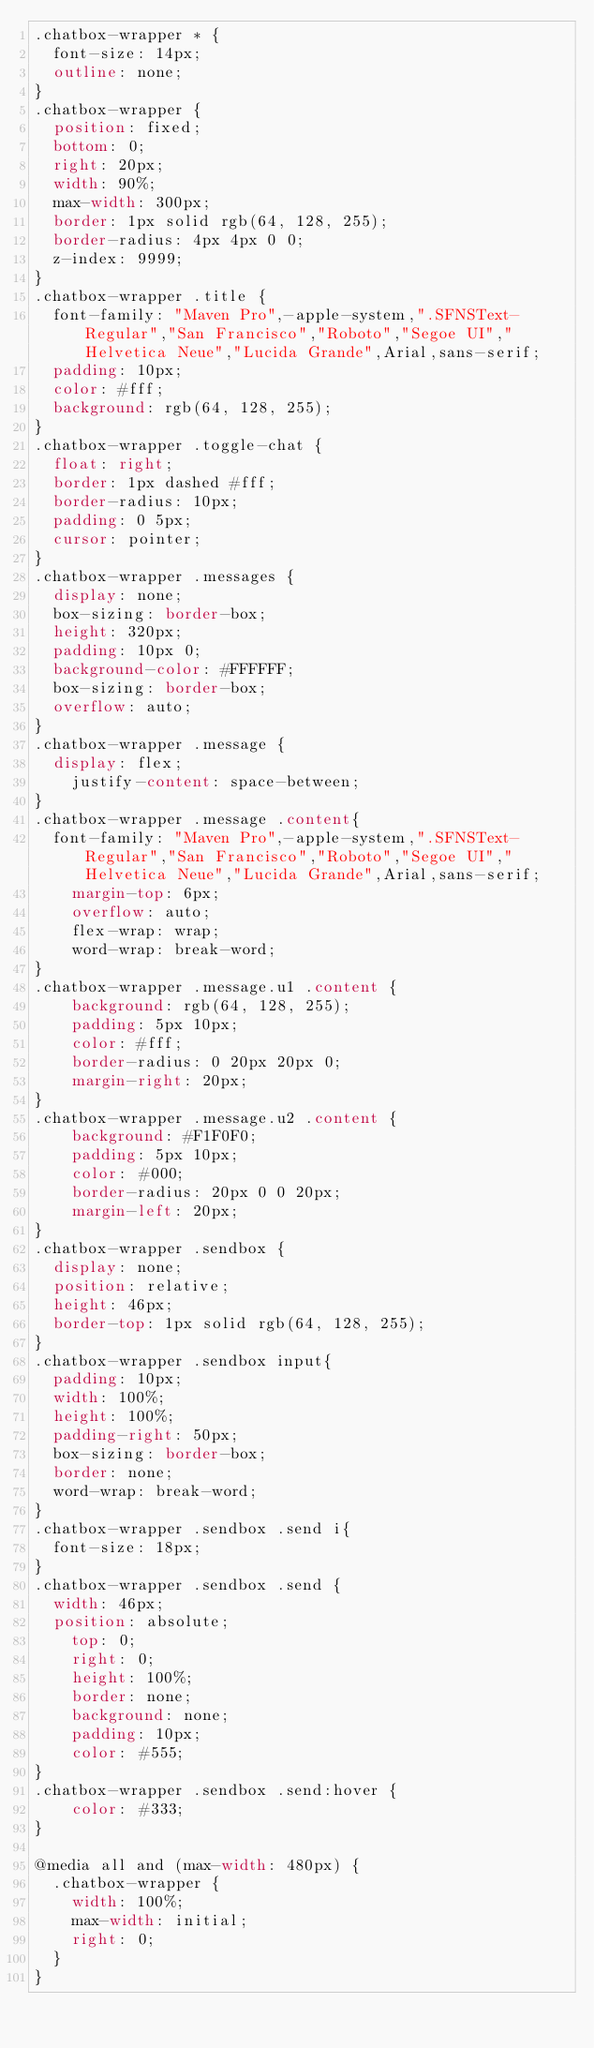Convert code to text. <code><loc_0><loc_0><loc_500><loc_500><_CSS_>.chatbox-wrapper * {
  font-size: 14px;
  outline: none;
}
.chatbox-wrapper {
  position: fixed;
  bottom: 0;
  right: 20px;
  width: 90%;
  max-width: 300px;
  border: 1px solid rgb(64, 128, 255);
  border-radius: 4px 4px 0 0;
  z-index: 9999;
}
.chatbox-wrapper .title {
  font-family: "Maven Pro",-apple-system,".SFNSText-Regular","San Francisco","Roboto","Segoe UI","Helvetica Neue","Lucida Grande",Arial,sans-serif;
  padding: 10px;
  color: #fff;
  background: rgb(64, 128, 255);
}
.chatbox-wrapper .toggle-chat {
  float: right;
  border: 1px dashed #fff;
  border-radius: 10px;
  padding: 0 5px;
  cursor: pointer;
}
.chatbox-wrapper .messages {
  display: none;
  box-sizing: border-box;
  height: 320px;
  padding: 10px 0;
  background-color: #FFFFFF;
  box-sizing: border-box;
  overflow: auto;
}
.chatbox-wrapper .message {
  display: flex;
    justify-content: space-between;
}
.chatbox-wrapper .message .content{
  font-family: "Maven Pro",-apple-system,".SFNSText-Regular","San Francisco","Roboto","Segoe UI","Helvetica Neue","Lucida Grande",Arial,sans-serif;
    margin-top: 6px;
    overflow: auto;
    flex-wrap: wrap;
    word-wrap: break-word;
}
.chatbox-wrapper .message.u1 .content {
    background: rgb(64, 128, 255);
    padding: 5px 10px;
    color: #fff;
    border-radius: 0 20px 20px 0;
    margin-right: 20px;
}
.chatbox-wrapper .message.u2 .content {
    background: #F1F0F0;
    padding: 5px 10px;
    color: #000;
    border-radius: 20px 0 0 20px;
    margin-left: 20px;
}
.chatbox-wrapper .sendbox {
  display: none;
  position: relative;
  height: 46px;
  border-top: 1px solid rgb(64, 128, 255);
}
.chatbox-wrapper .sendbox input{
  padding: 10px;
  width: 100%;
  height: 100%;
  padding-right: 50px;
  box-sizing: border-box;
  border: none;
  word-wrap: break-word;
}
.chatbox-wrapper .sendbox .send i{
  font-size: 18px;
}
.chatbox-wrapper .sendbox .send {
  width: 46px;
  position: absolute;
    top: 0;
    right: 0;
    height: 100%;
    border: none;
    background: none;
    padding: 10px;
    color: #555;
}
.chatbox-wrapper .sendbox .send:hover {
    color: #333;
}

@media all and (max-width: 480px) {
  .chatbox-wrapper {
    width: 100%;
    max-width: initial;
    right: 0;
  }
}</code> 